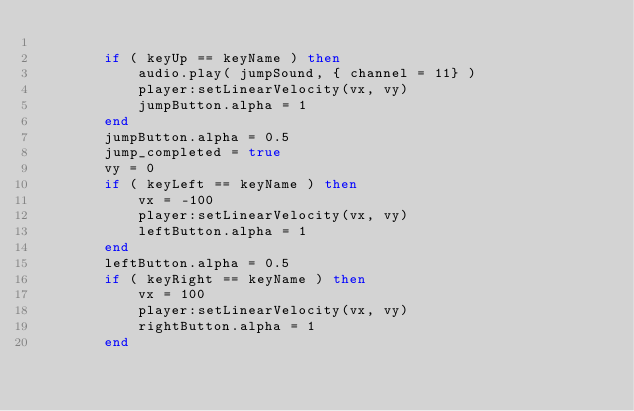Convert code to text. <code><loc_0><loc_0><loc_500><loc_500><_Lua_>
        if ( keyUp == keyName ) then
            audio.play( jumpSound, { channel = 11} )
            player:setLinearVelocity(vx, vy)
            jumpButton.alpha = 1
        end
        jumpButton.alpha = 0.5
        jump_completed = true
        vy = 0
        if ( keyLeft == keyName ) then
            vx = -100
            player:setLinearVelocity(vx, vy)
            leftButton.alpha = 1
        end
        leftButton.alpha = 0.5
        if ( keyRight == keyName ) then
            vx = 100
            player:setLinearVelocity(vx, vy)
            rightButton.alpha = 1
        end</code> 